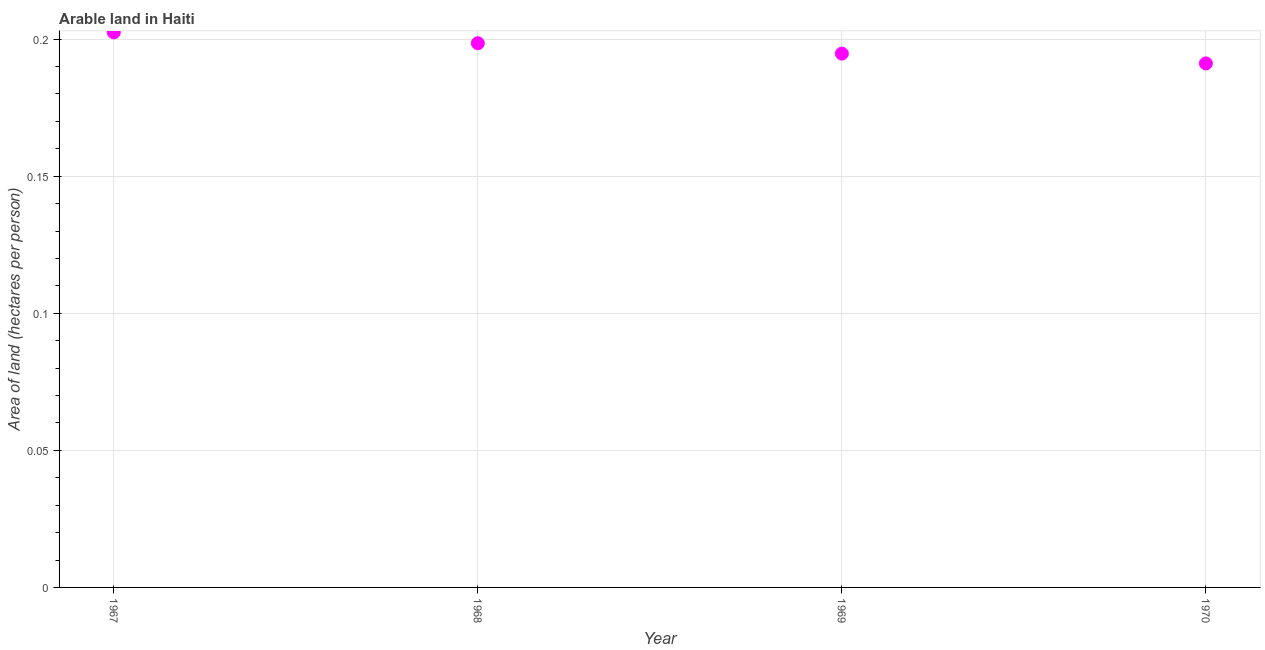What is the area of arable land in 1968?
Offer a very short reply. 0.2. Across all years, what is the maximum area of arable land?
Provide a short and direct response. 0.2. Across all years, what is the minimum area of arable land?
Give a very brief answer. 0.19. In which year was the area of arable land maximum?
Provide a succinct answer. 1967. What is the sum of the area of arable land?
Ensure brevity in your answer.  0.79. What is the difference between the area of arable land in 1968 and 1969?
Provide a short and direct response. 0. What is the average area of arable land per year?
Your answer should be very brief. 0.2. What is the median area of arable land?
Provide a succinct answer. 0.2. Do a majority of the years between 1967 and 1969 (inclusive) have area of arable land greater than 0.18000000000000002 hectares per person?
Your answer should be compact. Yes. What is the ratio of the area of arable land in 1967 to that in 1969?
Keep it short and to the point. 1.04. What is the difference between the highest and the second highest area of arable land?
Your answer should be very brief. 0. What is the difference between the highest and the lowest area of arable land?
Make the answer very short. 0.01. Does the area of arable land monotonically increase over the years?
Provide a short and direct response. No. What is the difference between two consecutive major ticks on the Y-axis?
Provide a succinct answer. 0.05. Does the graph contain any zero values?
Provide a short and direct response. No. Does the graph contain grids?
Provide a short and direct response. Yes. What is the title of the graph?
Provide a short and direct response. Arable land in Haiti. What is the label or title of the Y-axis?
Your answer should be very brief. Area of land (hectares per person). What is the Area of land (hectares per person) in 1967?
Your answer should be compact. 0.2. What is the Area of land (hectares per person) in 1968?
Ensure brevity in your answer.  0.2. What is the Area of land (hectares per person) in 1969?
Your answer should be compact. 0.19. What is the Area of land (hectares per person) in 1970?
Your response must be concise. 0.19. What is the difference between the Area of land (hectares per person) in 1967 and 1968?
Your answer should be compact. 0. What is the difference between the Area of land (hectares per person) in 1967 and 1969?
Keep it short and to the point. 0.01. What is the difference between the Area of land (hectares per person) in 1967 and 1970?
Keep it short and to the point. 0.01. What is the difference between the Area of land (hectares per person) in 1968 and 1969?
Give a very brief answer. 0. What is the difference between the Area of land (hectares per person) in 1968 and 1970?
Make the answer very short. 0.01. What is the difference between the Area of land (hectares per person) in 1969 and 1970?
Ensure brevity in your answer.  0. What is the ratio of the Area of land (hectares per person) in 1967 to that in 1969?
Keep it short and to the point. 1.04. What is the ratio of the Area of land (hectares per person) in 1967 to that in 1970?
Offer a very short reply. 1.06. What is the ratio of the Area of land (hectares per person) in 1968 to that in 1970?
Make the answer very short. 1.04. 